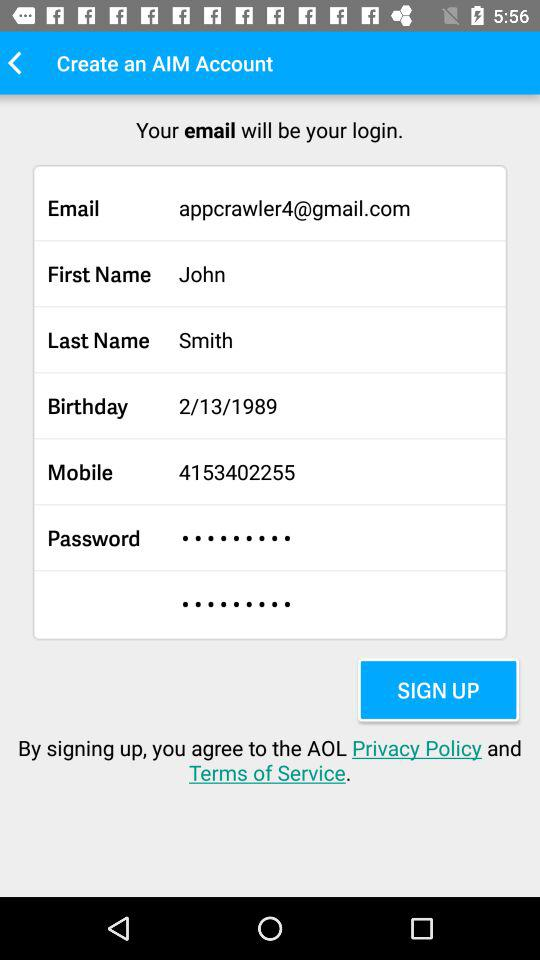What is the user's first name? The user's first name is John. 